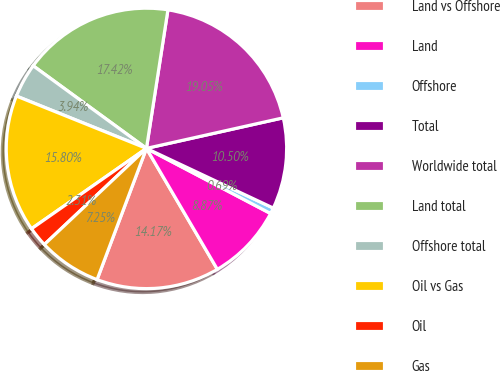<chart> <loc_0><loc_0><loc_500><loc_500><pie_chart><fcel>Land vs Offshore<fcel>Land<fcel>Offshore<fcel>Total<fcel>Worldwide total<fcel>Land total<fcel>Offshore total<fcel>Oil vs Gas<fcel>Oil<fcel>Gas<nl><fcel>14.17%<fcel>8.87%<fcel>0.69%<fcel>10.5%<fcel>19.05%<fcel>17.42%<fcel>3.94%<fcel>15.8%<fcel>2.31%<fcel>7.25%<nl></chart> 